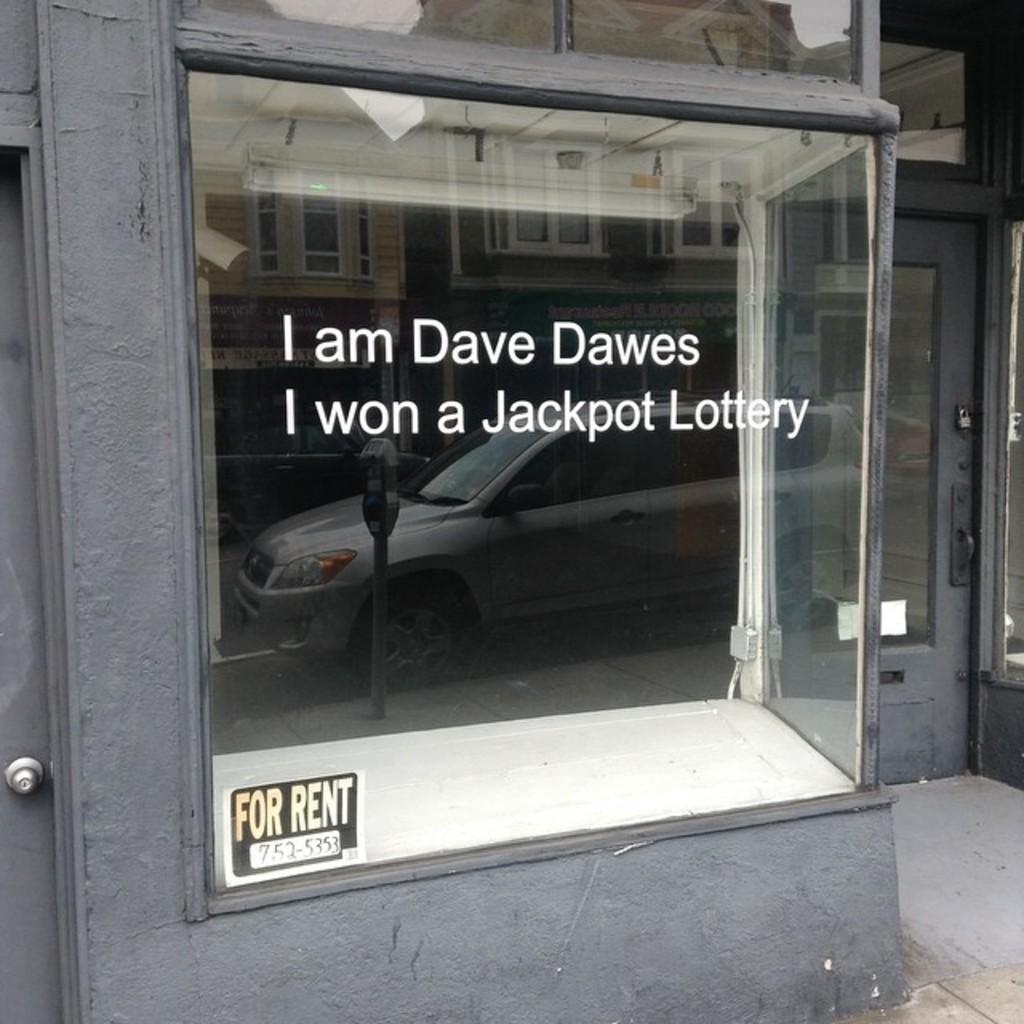What object is present in the image that can hold a liquid? There is a glass in the image. What is depicted on the glass? The glass has an image of a vehicle. Is there any text or information on the glass? Yes, there is a sticker for rent at the bottom of the glass. What type of nerve can be seen in the image? There is no nerve present in the image; it features a glass with an image of a vehicle and a sticker for rent. 